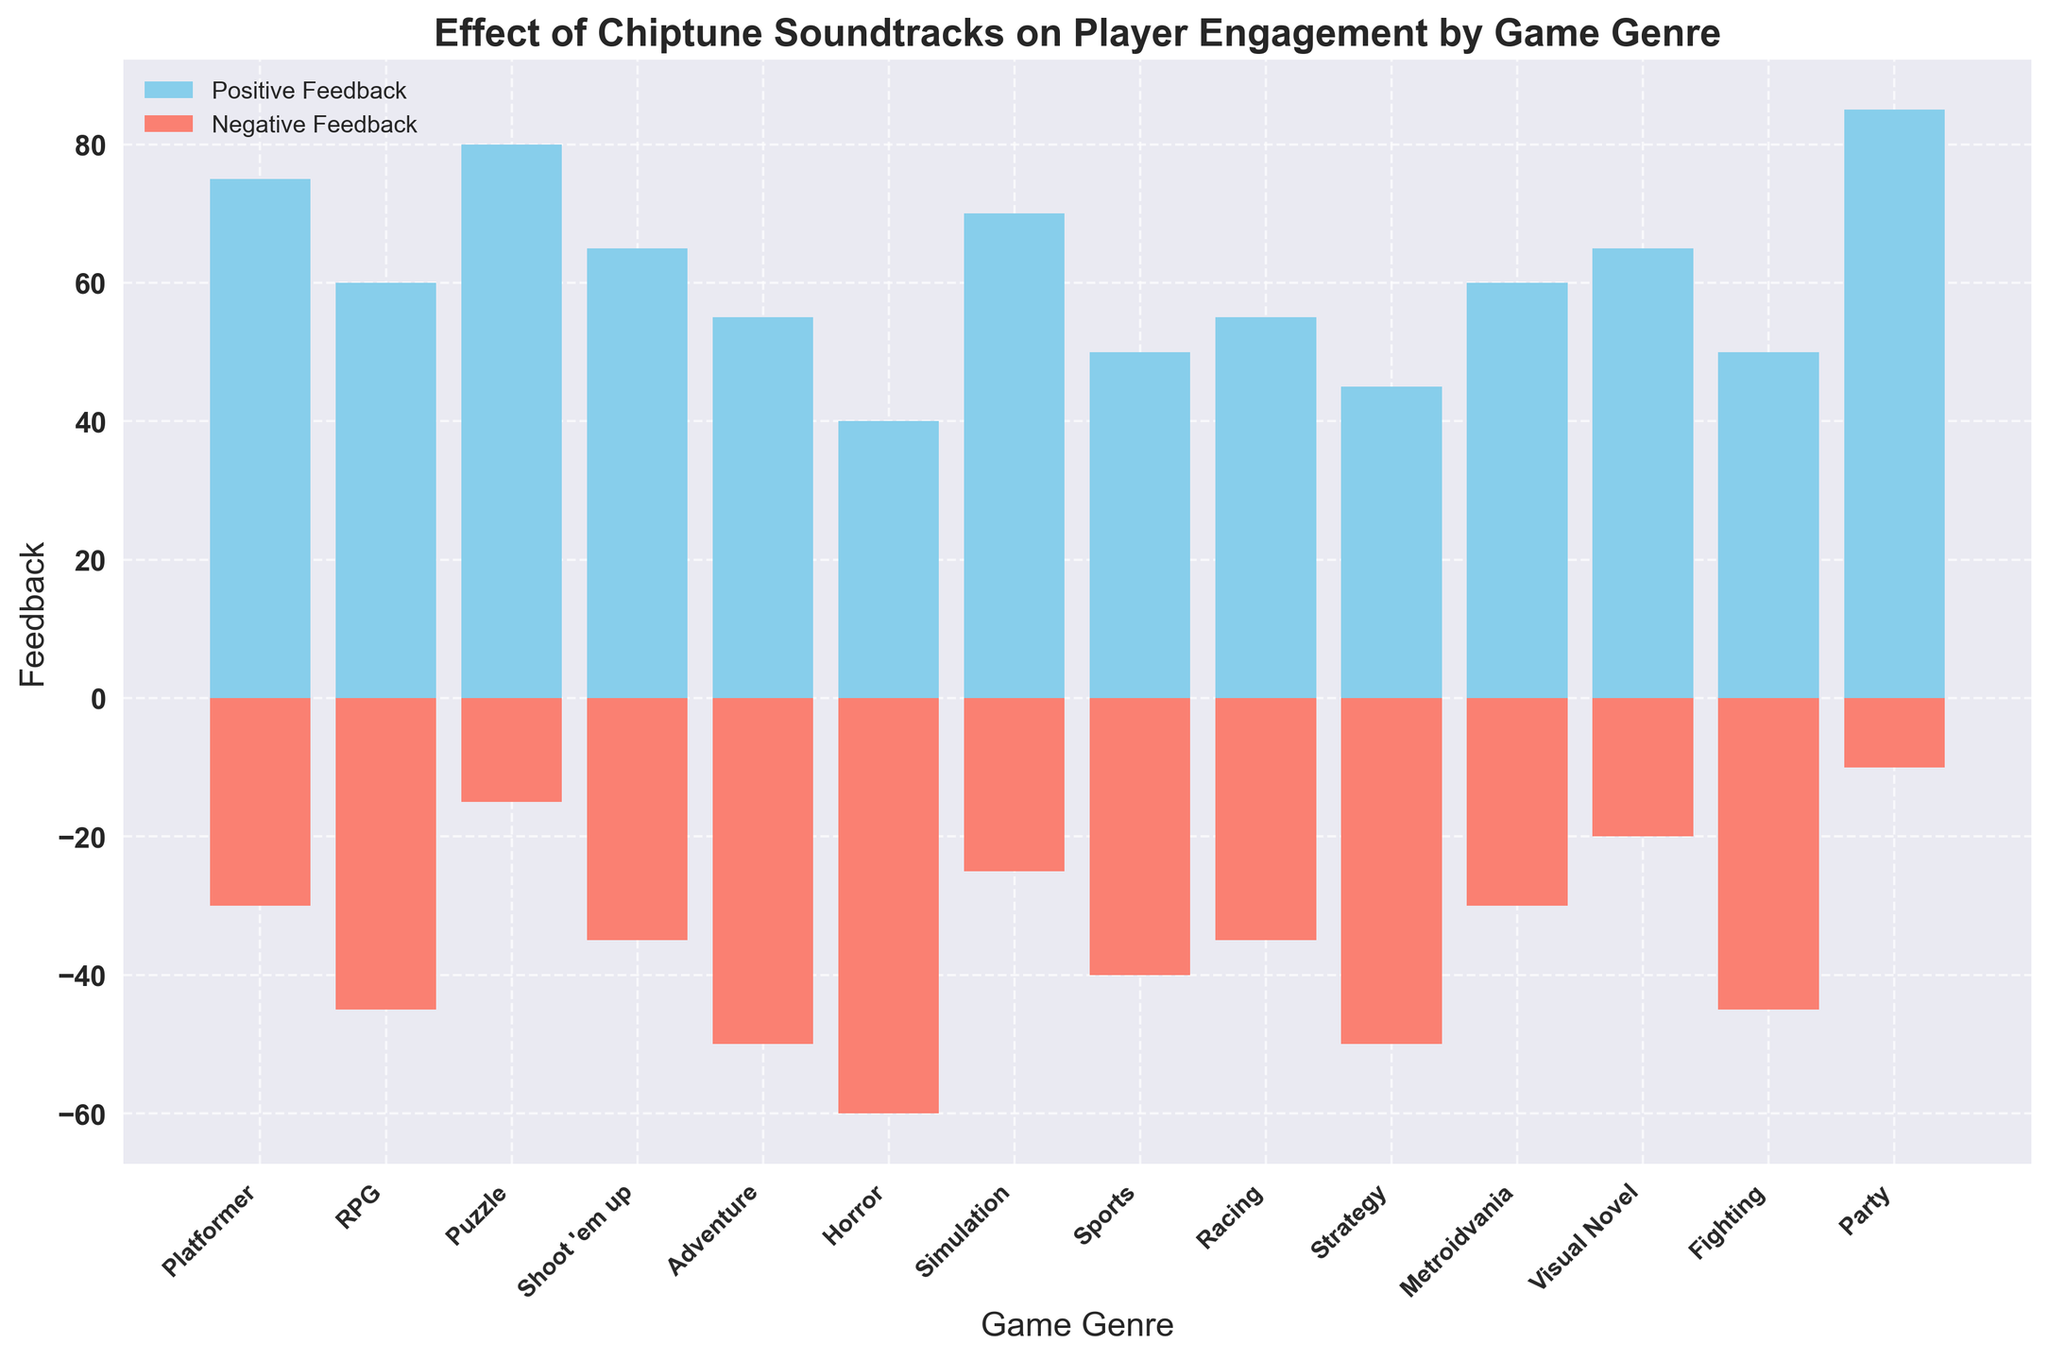Which game genre has the highest positive feedback? By examining the lengths of the bars representing positive feedback, the "Party" genre has the highest bar, indicating the most positive feedback.
Answer: Party What is the total amount of negative feedback for all game genres combined? Sum all the negative feedback values: -30 + (-45) + (-15) + (-35) + (-50) + (-60) + (-25) + (-40) + (-35) + (-50) + (-30) + (-20) + (-45) + (-10) = -490.
Answer: -490 How does the visual novel genre's positive feedback compare to its negative feedback? The positive feedback for "Visual Novel" is represented by a sky blue bar reaching up to 65, while the negative feedback is represented by a salmon bar reaching down to -20. Thus, the positive feedback is higher than the negative feedback for this genre.
Answer: Positive feedback is higher Which game genre has the largest difference between positive and negative feedback? Calculate the difference for each genre. The "Horror" genre has 40 positive feedback and -60 negative feedback, resulting in a difference of 100 (abs(40 - (-60)) = 100). This is the largest difference among all genres.
Answer: Horror Which genres have more negative feedback than positive feedback? Compare the lengths of the positive and negative bars for each genre. "RPG," "Adventure," "Horror," "Sports," "Strategy," and "Fighting" have taller negative feedback bars compared to their positive counterparts.
Answer: RPG, Adventure, Horror, Sports, Strategy, Fighting What is the average positive feedback across all game genres? Sum all the positive feedback values and divide by the number of genres. The sum is 75 + 60 + 80 + 65 + 55 + 40 + 70 + 50 + 55 + 45 + 60 + 65 + 50 + 85 = 855. Divide by the number of genres (14): 855 / 14 = 61.07.
Answer: 61.07 What game genre has the least negative feedback? The "Party" genre has the shortest bar for negative feedback, reaching down to -10, indicating the least negative feedback.
Answer: Party How much more positive feedback does the "Puzzle" genre have compared to the "Simulation" genre? The "Puzzle" genre has 80 positive feedback, while the "Simulation" genre has 70. The difference is 80 - 70 = 10.
Answer: 10 Are there any genres with the same amount of negative feedback? If yes, which ones? By observing the heights of the negative feedback bars, the "Adventure" and "Strategy" genres both have -50 negative feedback.
Answer: Adventure, Strategy If we consider only the genres with over 60 positive feedback, how much total positive feedback do they contribute? Identify genres with positive feedback greater than 60: Puzzle (80), Platformer (75), Visual Novel (65), Shoot 'em up (65), Metroidvania (60), and Party (85). Sum is 80 + 75 + 65 + 65 + 60 + 85 = 430.
Answer: 430 